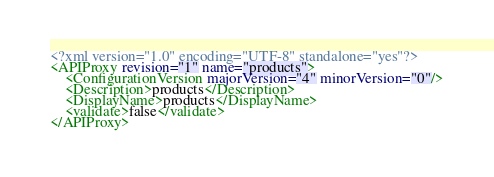Convert code to text. <code><loc_0><loc_0><loc_500><loc_500><_XML_><?xml version="1.0" encoding="UTF-8" standalone="yes"?>
<APIProxy revision="1" name="products">
    <ConfigurationVersion majorVersion="4" minorVersion="0"/>
    <Description>products</Description>
    <DisplayName>products</DisplayName>
    <validate>false</validate>
</APIProxy>
</code> 